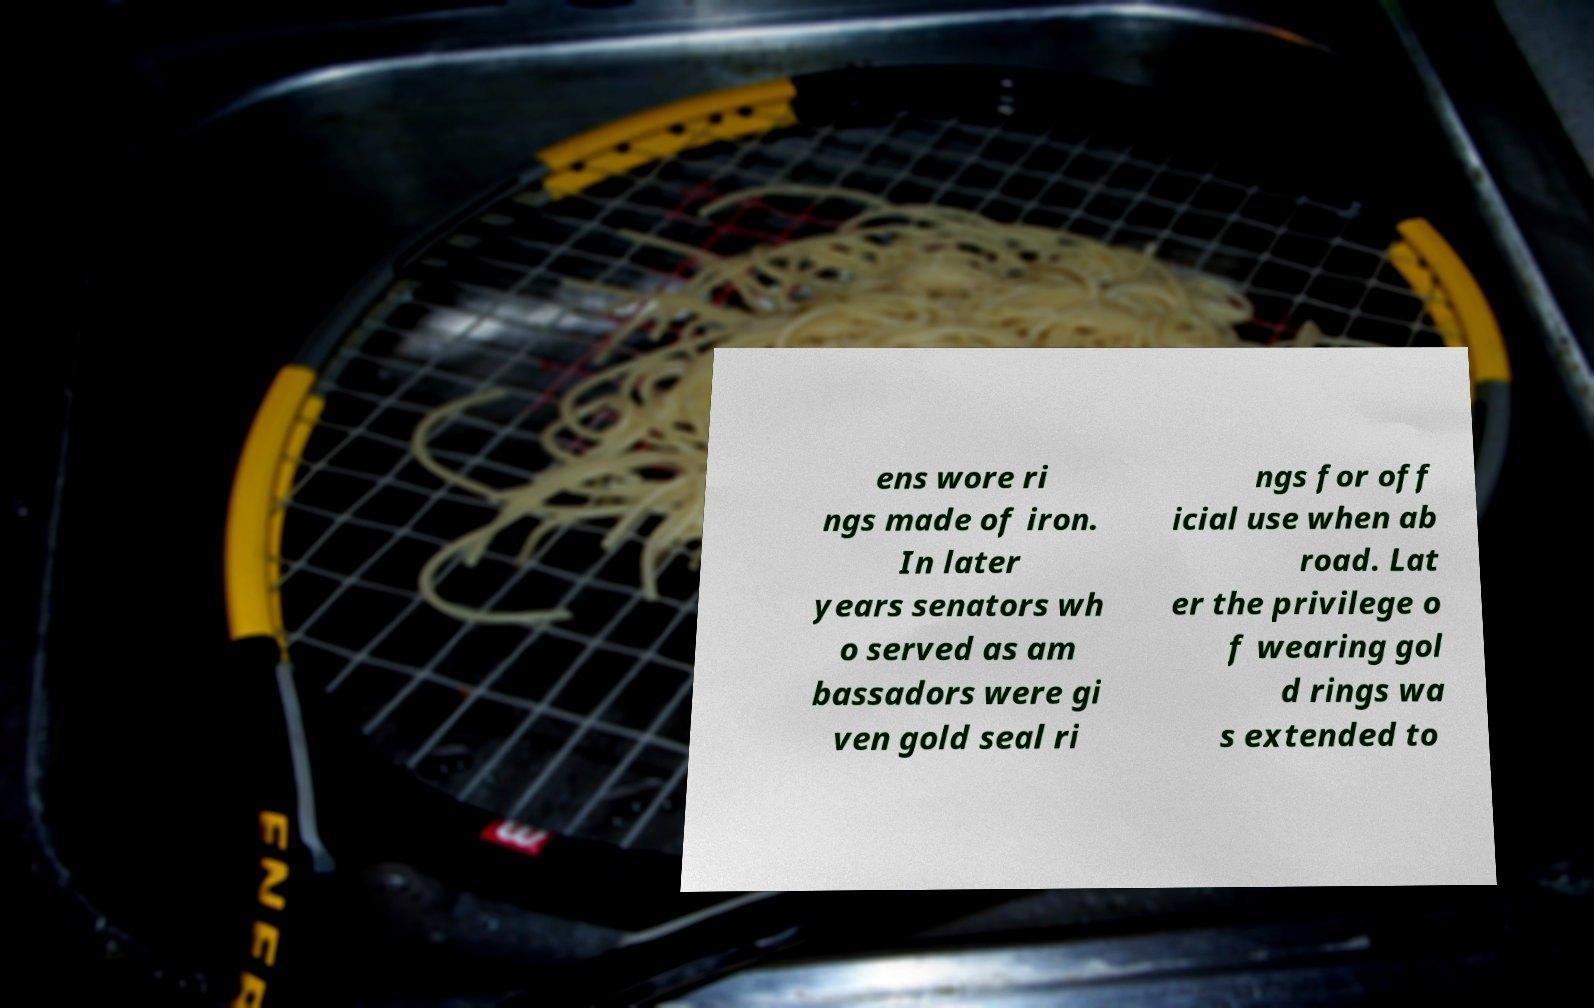What messages or text are displayed in this image? I need them in a readable, typed format. ens wore ri ngs made of iron. In later years senators wh o served as am bassadors were gi ven gold seal ri ngs for off icial use when ab road. Lat er the privilege o f wearing gol d rings wa s extended to 